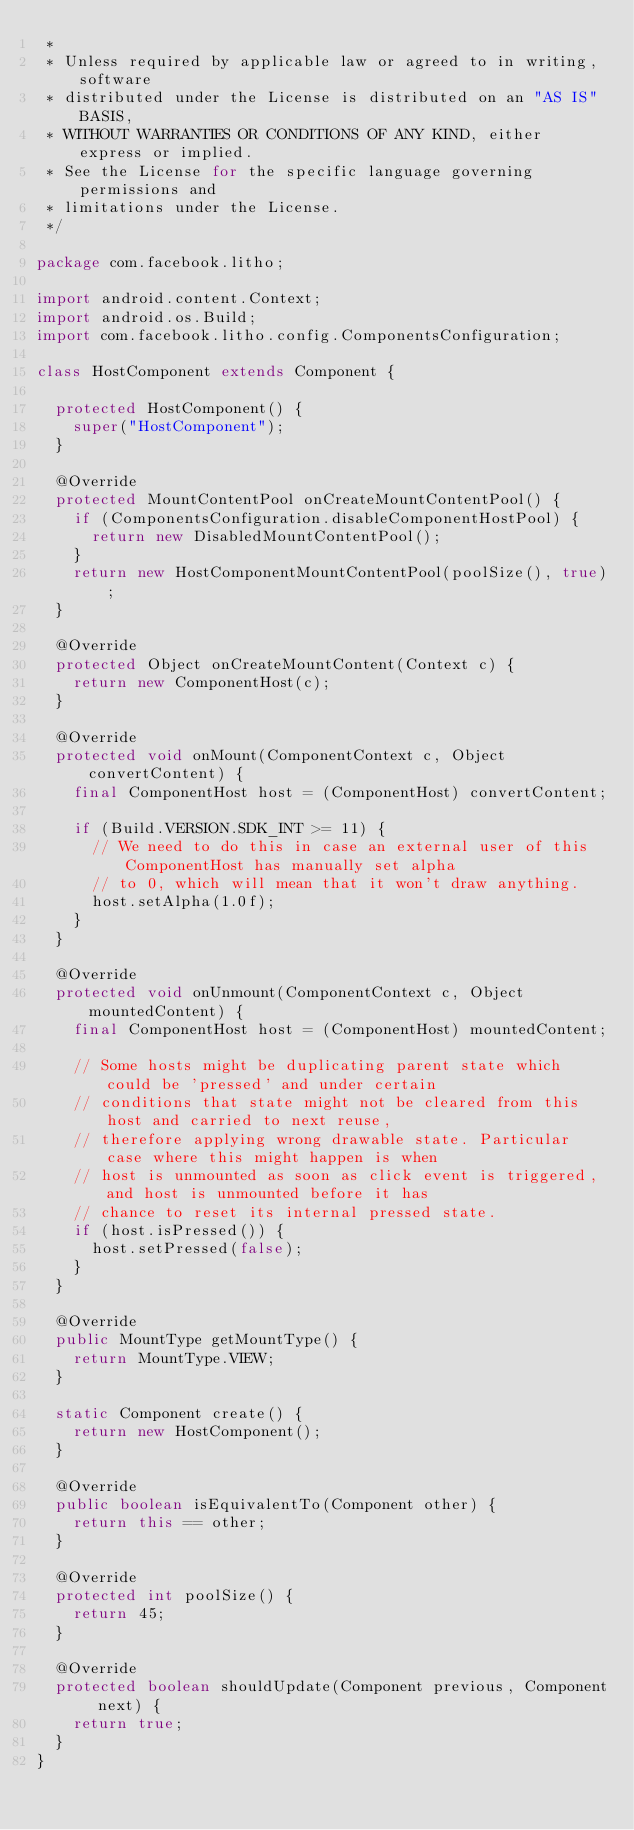<code> <loc_0><loc_0><loc_500><loc_500><_Java_> *
 * Unless required by applicable law or agreed to in writing, software
 * distributed under the License is distributed on an "AS IS" BASIS,
 * WITHOUT WARRANTIES OR CONDITIONS OF ANY KIND, either express or implied.
 * See the License for the specific language governing permissions and
 * limitations under the License.
 */

package com.facebook.litho;

import android.content.Context;
import android.os.Build;
import com.facebook.litho.config.ComponentsConfiguration;

class HostComponent extends Component {

  protected HostComponent() {
    super("HostComponent");
  }

  @Override
  protected MountContentPool onCreateMountContentPool() {
    if (ComponentsConfiguration.disableComponentHostPool) {
      return new DisabledMountContentPool();
    }
    return new HostComponentMountContentPool(poolSize(), true);
  }

  @Override
  protected Object onCreateMountContent(Context c) {
    return new ComponentHost(c);
  }

  @Override
  protected void onMount(ComponentContext c, Object convertContent) {
    final ComponentHost host = (ComponentHost) convertContent;

    if (Build.VERSION.SDK_INT >= 11) {
      // We need to do this in case an external user of this ComponentHost has manually set alpha
      // to 0, which will mean that it won't draw anything.
      host.setAlpha(1.0f);
    }
  }

  @Override
  protected void onUnmount(ComponentContext c, Object mountedContent) {
    final ComponentHost host = (ComponentHost) mountedContent;

    // Some hosts might be duplicating parent state which could be 'pressed' and under certain
    // conditions that state might not be cleared from this host and carried to next reuse,
    // therefore applying wrong drawable state. Particular case where this might happen is when
    // host is unmounted as soon as click event is triggered, and host is unmounted before it has
    // chance to reset its internal pressed state.
    if (host.isPressed()) {
      host.setPressed(false);
    }
  }

  @Override
  public MountType getMountType() {
    return MountType.VIEW;
  }

  static Component create() {
    return new HostComponent();
  }

  @Override
  public boolean isEquivalentTo(Component other) {
    return this == other;
  }

  @Override
  protected int poolSize() {
    return 45;
  }

  @Override
  protected boolean shouldUpdate(Component previous, Component next) {
    return true;
  }
}
</code> 